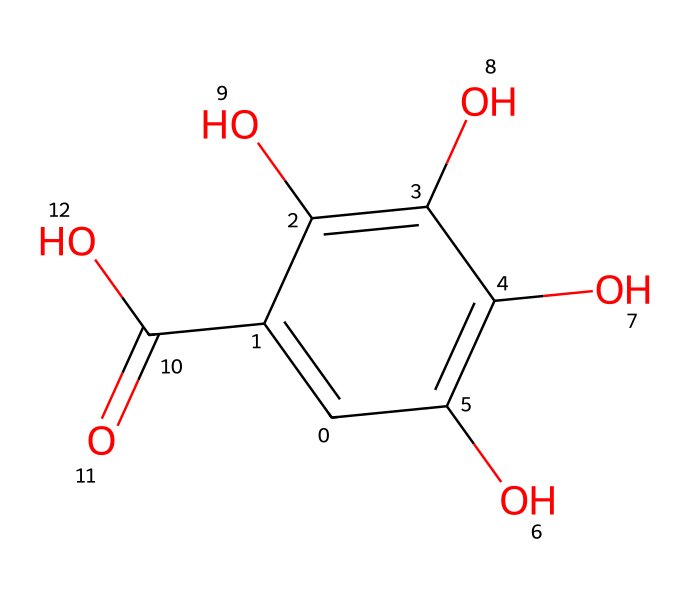What is the primary functional group present in gallic acid? Gallic acid contains multiple hydroxyl (–OH) groups, which are characteristic of phenolic compounds. The presence of these hydroxyl groups indicates the primary functional group is phenol.
Answer: phenol How many hydroxyl groups are present in gallic acid? In the SMILES representation, there are three –OH groups indicated, which shows that gallic acid has three hydroxyl groups attached to the aromatic ring.
Answer: three What type of compound is gallic acid categorized as? Gallic acid is categorized as a polyphenolic compound due to its multiple phenolic hydroxyl groups contributing to its antioxidant properties.
Answer: polyphenol What is the molecular formula of gallic acid? By analyzing the SMILES structure, we can count the carbon (C), hydrogen (H), and oxygen (O) atoms: there are 7 carbon atoms, 6 hydrogen atoms, and 5 oxygen atoms, leading to the molecular formula C7H6O5.
Answer: C7H6O5 What is the total number of rings present in gallic acid? In the structure of gallic acid, there is one aromatic ring, confirming that the compound has a single ring present.
Answer: one How does gallic acid contribute to antioxidant activity? The multiple hydroxyl groups in gallic acid can donate hydrogen atoms, which allows it to neutralize free radicals, thus providing antioxidant activity.
Answer: antioxidant What type of linkage connects the hydroxyl groups to the aromatic ring in gallic acid? The hydroxyl groups are connected to the aromatic ring via simple bonds, specifically through a phenolic linkage due to their direct attachment to the carbon atoms of the ring.
Answer: phenolic linkage 